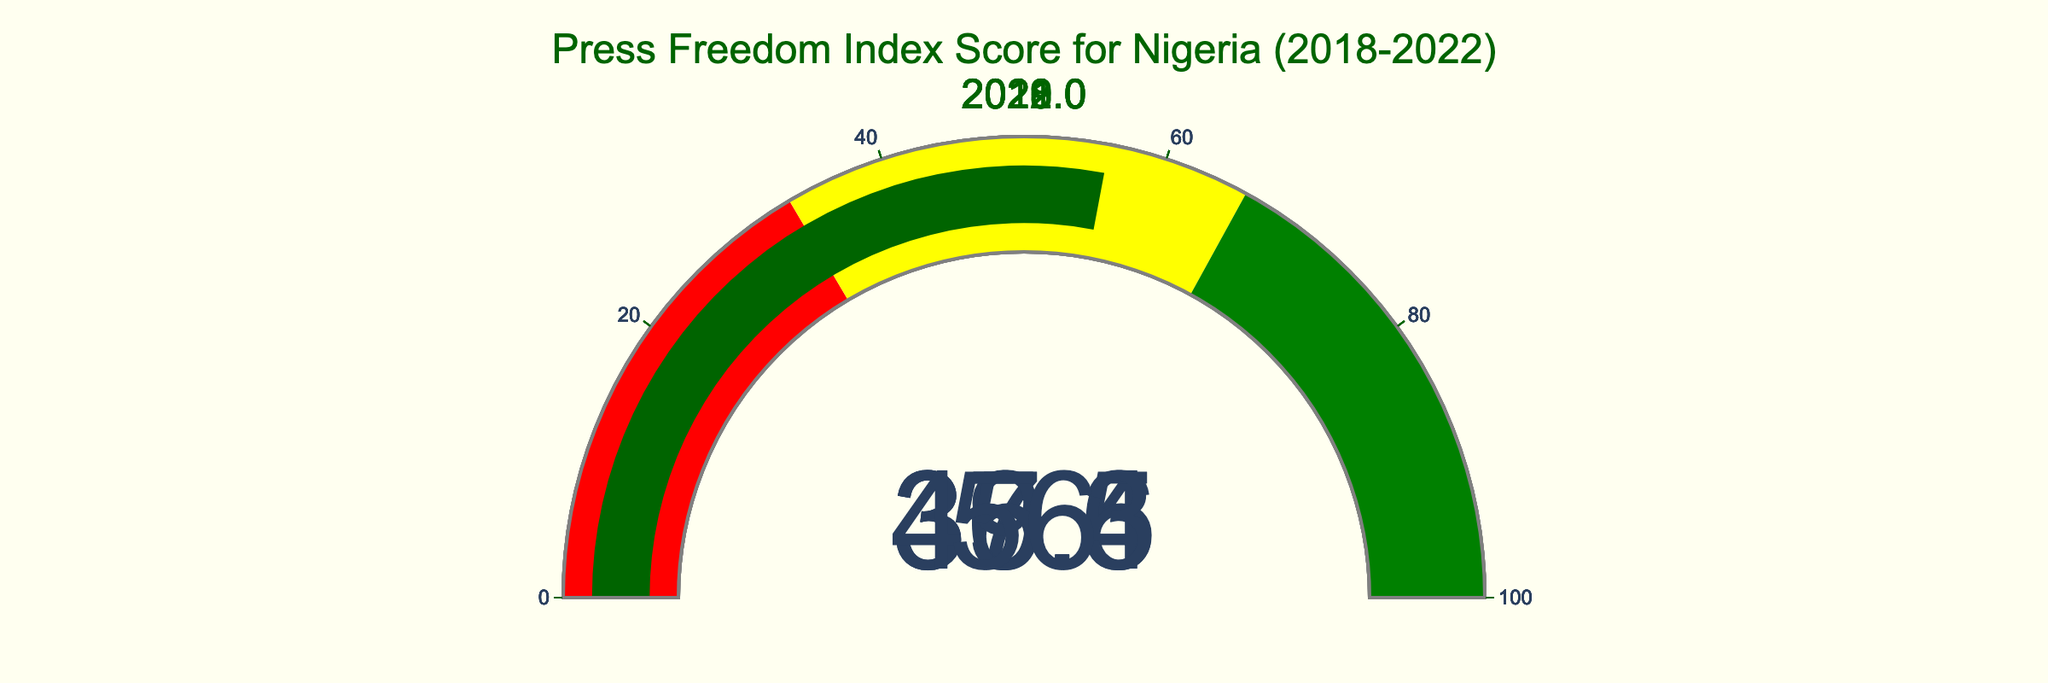What's the title of the figure? The title is displayed prominently at the top of the figure within the layout settings.
Answer: Press Freedom Index Score for Nigeria (2018-2022) How many gauge charts are displayed in the figure? By visually counting, each year in the dataset from 2018 to 2022 has its own gauge chart.
Answer: 5 In which year did Nigeria have the highest Press Freedom Index Score? By examining the individual gauge charts for each year, the highest number shown is for the year 2022.
Answer: 2022 What is the difference in Press Freedom Index Scores between 2022 and 2018? Subtract the value for 2018 (37.41) from the value for 2022 (55.95).
Answer: 18.54 Which year has a lower Press Freedom Index Score: 2019 or 2021? Compare the values shown on the gauges for 2019 (36.50) and 2021 (45.33).
Answer: 2019 What's the average Press Freedom Index Score over the five years displayed? Sum the scores for all five years and divide by the number of years: (55.95 + 45.33 + 39.58 + 36.50 + 37.41) / 5.
Answer: 42.95 Did Nigeria's Press Freedom Index Score improve or worsen from 2019 to 2020? Compare the values for 2019 (36.50) and 2020 (39.58); a higher score in 2020 indicates improvement.
Answer: Improved What is the Press Freedom Index Score for 2018? Look at the gauge chart labeled 2018.
Answer: 37.41 How many years had a Press Freedom Index Score above 40? Count the years where the gauge charts display values above 40: 2021 and 2022.
Answer: 2 By how much did the Press Freedom Index Score increase from the lowest year to the highest year? Subtract the lowest score (2019, 36.50) from the highest score (2022, 55.95).
Answer: 19.45 